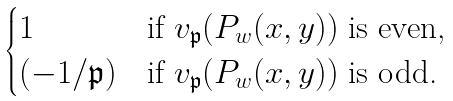Convert formula to latex. <formula><loc_0><loc_0><loc_500><loc_500>\begin{cases} 1 & \text {if $v_{\mathfrak{p}}(P_{w}(x,y))$ is even,} \\ ( - 1 / \mathfrak { p } ) & \text {if $v_{\mathfrak{p}}(P_{w}(x,y))$ is odd.} \end{cases}</formula> 